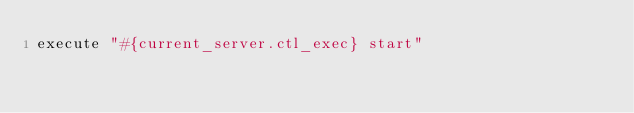Convert code to text. <code><loc_0><loc_0><loc_500><loc_500><_Ruby_>execute "#{current_server.ctl_exec} start"
</code> 